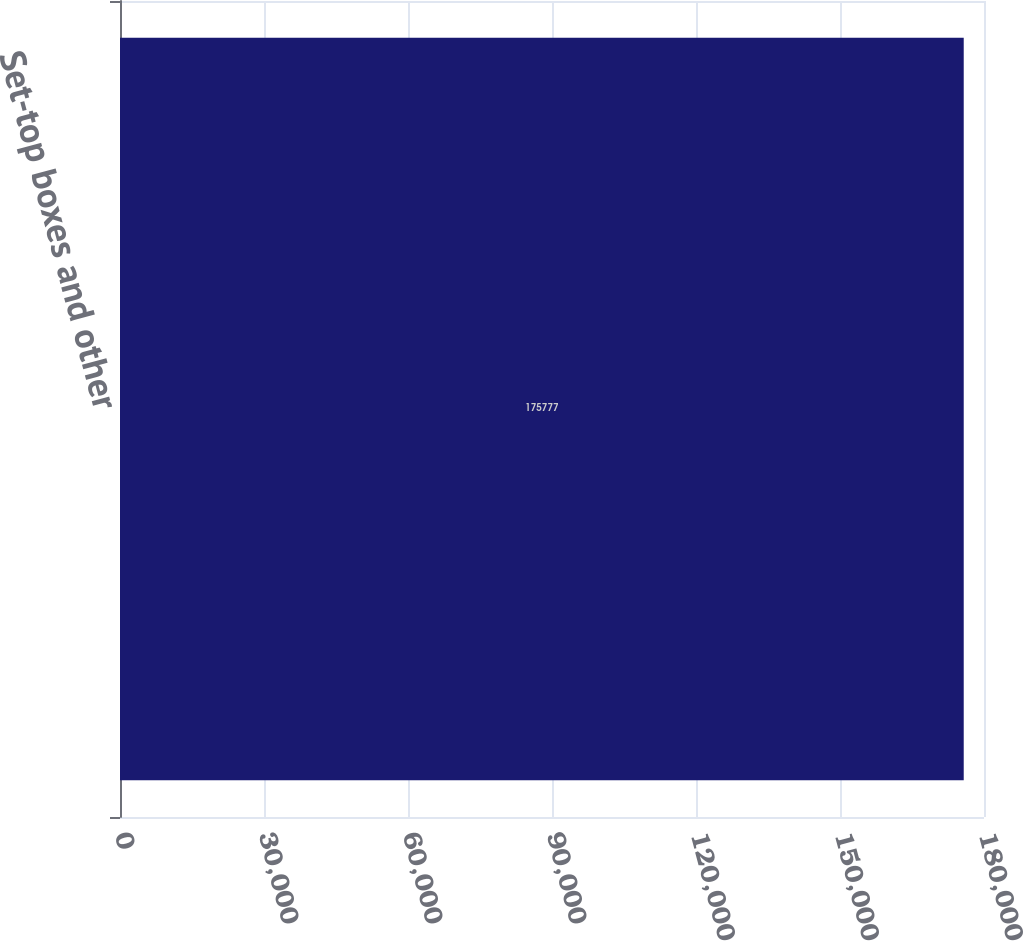Convert chart to OTSL. <chart><loc_0><loc_0><loc_500><loc_500><bar_chart><fcel>Set-top boxes and other<nl><fcel>175777<nl></chart> 